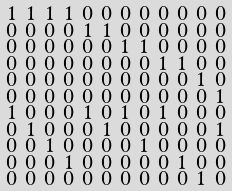Convert formula to latex. <formula><loc_0><loc_0><loc_500><loc_500>\begin{smallmatrix} 1 & 1 & 1 & 1 & 0 & 0 & 0 & 0 & 0 & 0 & 0 & 0 \\ 0 & 0 & 0 & 0 & 1 & 1 & 0 & 0 & 0 & 0 & 0 & 0 \\ 0 & 0 & 0 & 0 & 0 & 0 & 1 & 1 & 0 & 0 & 0 & 0 \\ 0 & 0 & 0 & 0 & 0 & 0 & 0 & 0 & 1 & 1 & 0 & 0 \\ 0 & 0 & 0 & 0 & 0 & 0 & 0 & 0 & 0 & 0 & 1 & 0 \\ 0 & 0 & 0 & 0 & 0 & 0 & 0 & 0 & 0 & 0 & 0 & 1 \\ 1 & 0 & 0 & 0 & 1 & 0 & 1 & 0 & 1 & 0 & 0 & 0 \\ 0 & 1 & 0 & 0 & 0 & 1 & 0 & 0 & 0 & 0 & 0 & 1 \\ 0 & 0 & 1 & 0 & 0 & 0 & 0 & 1 & 0 & 0 & 0 & 0 \\ 0 & 0 & 0 & 1 & 0 & 0 & 0 & 0 & 0 & 1 & 0 & 0 \\ 0 & 0 & 0 & 0 & 0 & 0 & 0 & 0 & 0 & 0 & 1 & 0 \\ \end{smallmatrix}</formula> 